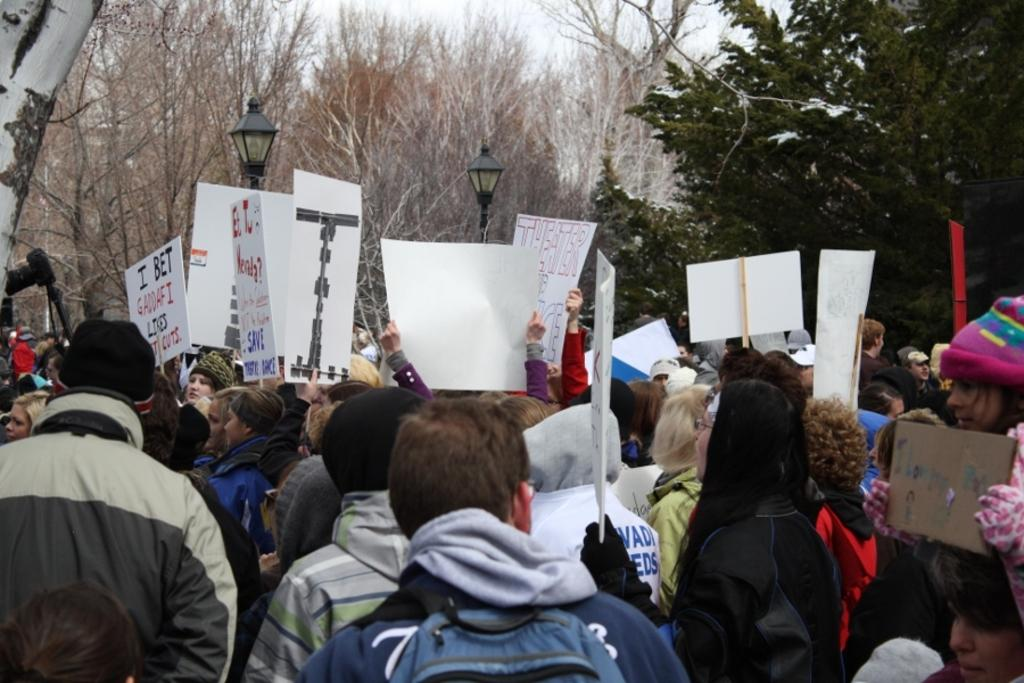Who or what is present in the image? There are people in the image. What are the people holding in the image? The people are holding posters. What can be seen in the background of the image? There are lanterns and trees in the background of the image. Where is the bed located in the image? There is no bed present in the image. What type of seashore can be seen in the image? There is no seashore present in the image. 